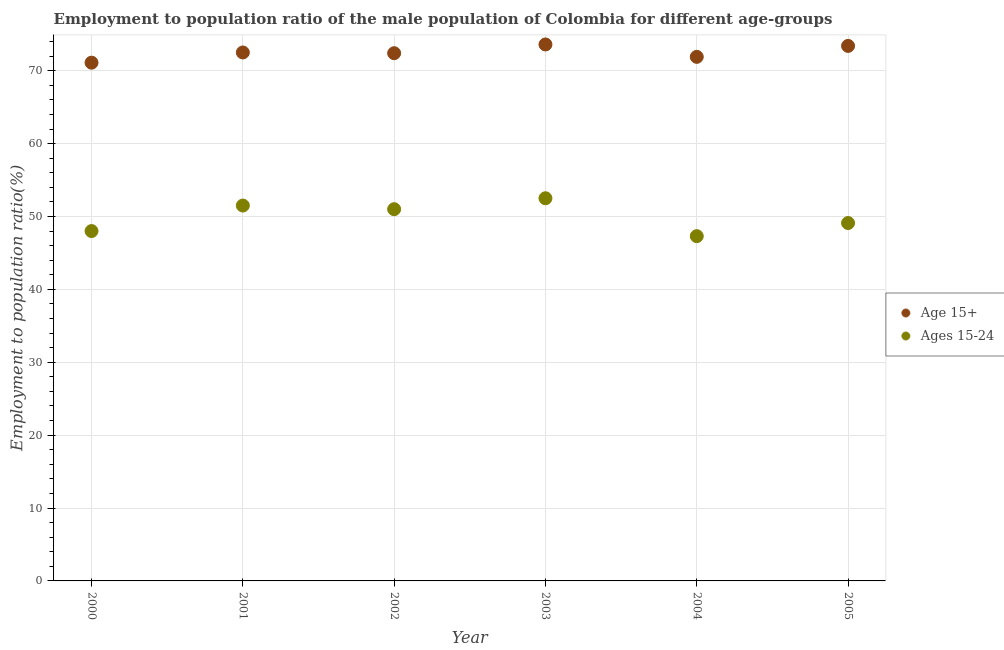How many different coloured dotlines are there?
Your answer should be compact. 2. Is the number of dotlines equal to the number of legend labels?
Ensure brevity in your answer.  Yes. What is the employment to population ratio(age 15-24) in 2001?
Offer a terse response. 51.5. Across all years, what is the maximum employment to population ratio(age 15+)?
Your response must be concise. 73.6. Across all years, what is the minimum employment to population ratio(age 15-24)?
Offer a terse response. 47.3. In which year was the employment to population ratio(age 15+) minimum?
Your answer should be compact. 2000. What is the total employment to population ratio(age 15+) in the graph?
Offer a very short reply. 434.9. What is the difference between the employment to population ratio(age 15-24) in 2002 and that in 2003?
Keep it short and to the point. -1.5. What is the difference between the employment to population ratio(age 15+) in 2003 and the employment to population ratio(age 15-24) in 2002?
Offer a very short reply. 22.6. What is the average employment to population ratio(age 15+) per year?
Offer a terse response. 72.48. In the year 2004, what is the difference between the employment to population ratio(age 15+) and employment to population ratio(age 15-24)?
Make the answer very short. 24.6. In how many years, is the employment to population ratio(age 15-24) greater than 28 %?
Your response must be concise. 6. What is the ratio of the employment to population ratio(age 15-24) in 2002 to that in 2003?
Provide a short and direct response. 0.97. Is the employment to population ratio(age 15+) in 2000 less than that in 2004?
Make the answer very short. Yes. What is the difference between the highest and the second highest employment to population ratio(age 15+)?
Provide a short and direct response. 0.2. In how many years, is the employment to population ratio(age 15-24) greater than the average employment to population ratio(age 15-24) taken over all years?
Ensure brevity in your answer.  3. Is the sum of the employment to population ratio(age 15-24) in 2000 and 2002 greater than the maximum employment to population ratio(age 15+) across all years?
Ensure brevity in your answer.  Yes. Does the employment to population ratio(age 15+) monotonically increase over the years?
Provide a short and direct response. No. Is the employment to population ratio(age 15-24) strictly greater than the employment to population ratio(age 15+) over the years?
Provide a short and direct response. No. Is the employment to population ratio(age 15-24) strictly less than the employment to population ratio(age 15+) over the years?
Your response must be concise. Yes. How many years are there in the graph?
Your answer should be compact. 6. Does the graph contain grids?
Offer a terse response. Yes. How many legend labels are there?
Offer a very short reply. 2. What is the title of the graph?
Make the answer very short. Employment to population ratio of the male population of Colombia for different age-groups. What is the label or title of the Y-axis?
Offer a very short reply. Employment to population ratio(%). What is the Employment to population ratio(%) in Age 15+ in 2000?
Ensure brevity in your answer.  71.1. What is the Employment to population ratio(%) of Age 15+ in 2001?
Ensure brevity in your answer.  72.5. What is the Employment to population ratio(%) in Ages 15-24 in 2001?
Keep it short and to the point. 51.5. What is the Employment to population ratio(%) of Age 15+ in 2002?
Ensure brevity in your answer.  72.4. What is the Employment to population ratio(%) of Age 15+ in 2003?
Give a very brief answer. 73.6. What is the Employment to population ratio(%) of Ages 15-24 in 2003?
Offer a terse response. 52.5. What is the Employment to population ratio(%) in Age 15+ in 2004?
Offer a very short reply. 71.9. What is the Employment to population ratio(%) of Ages 15-24 in 2004?
Offer a terse response. 47.3. What is the Employment to population ratio(%) in Age 15+ in 2005?
Your answer should be very brief. 73.4. What is the Employment to population ratio(%) in Ages 15-24 in 2005?
Your answer should be very brief. 49.1. Across all years, what is the maximum Employment to population ratio(%) in Age 15+?
Ensure brevity in your answer.  73.6. Across all years, what is the maximum Employment to population ratio(%) of Ages 15-24?
Your answer should be compact. 52.5. Across all years, what is the minimum Employment to population ratio(%) in Age 15+?
Your answer should be very brief. 71.1. Across all years, what is the minimum Employment to population ratio(%) of Ages 15-24?
Give a very brief answer. 47.3. What is the total Employment to population ratio(%) in Age 15+ in the graph?
Provide a succinct answer. 434.9. What is the total Employment to population ratio(%) in Ages 15-24 in the graph?
Your answer should be very brief. 299.4. What is the difference between the Employment to population ratio(%) of Ages 15-24 in 2000 and that in 2002?
Provide a short and direct response. -3. What is the difference between the Employment to population ratio(%) in Age 15+ in 2000 and that in 2004?
Keep it short and to the point. -0.8. What is the difference between the Employment to population ratio(%) of Ages 15-24 in 2000 and that in 2004?
Offer a very short reply. 0.7. What is the difference between the Employment to population ratio(%) in Ages 15-24 in 2000 and that in 2005?
Provide a succinct answer. -1.1. What is the difference between the Employment to population ratio(%) in Age 15+ in 2001 and that in 2002?
Your answer should be compact. 0.1. What is the difference between the Employment to population ratio(%) in Ages 15-24 in 2001 and that in 2002?
Give a very brief answer. 0.5. What is the difference between the Employment to population ratio(%) of Age 15+ in 2001 and that in 2003?
Offer a very short reply. -1.1. What is the difference between the Employment to population ratio(%) in Age 15+ in 2001 and that in 2005?
Provide a short and direct response. -0.9. What is the difference between the Employment to population ratio(%) in Ages 15-24 in 2002 and that in 2003?
Your answer should be very brief. -1.5. What is the difference between the Employment to population ratio(%) of Age 15+ in 2002 and that in 2004?
Your response must be concise. 0.5. What is the difference between the Employment to population ratio(%) in Age 15+ in 2003 and that in 2005?
Ensure brevity in your answer.  0.2. What is the difference between the Employment to population ratio(%) in Age 15+ in 2000 and the Employment to population ratio(%) in Ages 15-24 in 2001?
Provide a short and direct response. 19.6. What is the difference between the Employment to population ratio(%) in Age 15+ in 2000 and the Employment to population ratio(%) in Ages 15-24 in 2002?
Your response must be concise. 20.1. What is the difference between the Employment to population ratio(%) of Age 15+ in 2000 and the Employment to population ratio(%) of Ages 15-24 in 2003?
Provide a short and direct response. 18.6. What is the difference between the Employment to population ratio(%) of Age 15+ in 2000 and the Employment to population ratio(%) of Ages 15-24 in 2004?
Your answer should be compact. 23.8. What is the difference between the Employment to population ratio(%) in Age 15+ in 2000 and the Employment to population ratio(%) in Ages 15-24 in 2005?
Offer a terse response. 22. What is the difference between the Employment to population ratio(%) of Age 15+ in 2001 and the Employment to population ratio(%) of Ages 15-24 in 2002?
Make the answer very short. 21.5. What is the difference between the Employment to population ratio(%) of Age 15+ in 2001 and the Employment to population ratio(%) of Ages 15-24 in 2003?
Offer a very short reply. 20. What is the difference between the Employment to population ratio(%) in Age 15+ in 2001 and the Employment to population ratio(%) in Ages 15-24 in 2004?
Your response must be concise. 25.2. What is the difference between the Employment to population ratio(%) of Age 15+ in 2001 and the Employment to population ratio(%) of Ages 15-24 in 2005?
Your answer should be compact. 23.4. What is the difference between the Employment to population ratio(%) in Age 15+ in 2002 and the Employment to population ratio(%) in Ages 15-24 in 2003?
Offer a very short reply. 19.9. What is the difference between the Employment to population ratio(%) of Age 15+ in 2002 and the Employment to population ratio(%) of Ages 15-24 in 2004?
Keep it short and to the point. 25.1. What is the difference between the Employment to population ratio(%) in Age 15+ in 2002 and the Employment to population ratio(%) in Ages 15-24 in 2005?
Ensure brevity in your answer.  23.3. What is the difference between the Employment to population ratio(%) of Age 15+ in 2003 and the Employment to population ratio(%) of Ages 15-24 in 2004?
Ensure brevity in your answer.  26.3. What is the difference between the Employment to population ratio(%) of Age 15+ in 2003 and the Employment to population ratio(%) of Ages 15-24 in 2005?
Your answer should be very brief. 24.5. What is the difference between the Employment to population ratio(%) of Age 15+ in 2004 and the Employment to population ratio(%) of Ages 15-24 in 2005?
Ensure brevity in your answer.  22.8. What is the average Employment to population ratio(%) in Age 15+ per year?
Offer a very short reply. 72.48. What is the average Employment to population ratio(%) in Ages 15-24 per year?
Your response must be concise. 49.9. In the year 2000, what is the difference between the Employment to population ratio(%) in Age 15+ and Employment to population ratio(%) in Ages 15-24?
Give a very brief answer. 23.1. In the year 2002, what is the difference between the Employment to population ratio(%) in Age 15+ and Employment to population ratio(%) in Ages 15-24?
Your answer should be very brief. 21.4. In the year 2003, what is the difference between the Employment to population ratio(%) of Age 15+ and Employment to population ratio(%) of Ages 15-24?
Keep it short and to the point. 21.1. In the year 2004, what is the difference between the Employment to population ratio(%) of Age 15+ and Employment to population ratio(%) of Ages 15-24?
Your answer should be very brief. 24.6. In the year 2005, what is the difference between the Employment to population ratio(%) of Age 15+ and Employment to population ratio(%) of Ages 15-24?
Your answer should be very brief. 24.3. What is the ratio of the Employment to population ratio(%) in Age 15+ in 2000 to that in 2001?
Your answer should be compact. 0.98. What is the ratio of the Employment to population ratio(%) in Ages 15-24 in 2000 to that in 2001?
Give a very brief answer. 0.93. What is the ratio of the Employment to population ratio(%) in Age 15+ in 2000 to that in 2003?
Your answer should be compact. 0.97. What is the ratio of the Employment to population ratio(%) in Ages 15-24 in 2000 to that in 2003?
Offer a terse response. 0.91. What is the ratio of the Employment to population ratio(%) in Age 15+ in 2000 to that in 2004?
Make the answer very short. 0.99. What is the ratio of the Employment to population ratio(%) of Ages 15-24 in 2000 to that in 2004?
Your answer should be compact. 1.01. What is the ratio of the Employment to population ratio(%) of Age 15+ in 2000 to that in 2005?
Your response must be concise. 0.97. What is the ratio of the Employment to population ratio(%) in Ages 15-24 in 2000 to that in 2005?
Offer a very short reply. 0.98. What is the ratio of the Employment to population ratio(%) in Ages 15-24 in 2001 to that in 2002?
Provide a succinct answer. 1.01. What is the ratio of the Employment to population ratio(%) of Age 15+ in 2001 to that in 2003?
Ensure brevity in your answer.  0.99. What is the ratio of the Employment to population ratio(%) in Ages 15-24 in 2001 to that in 2003?
Your answer should be very brief. 0.98. What is the ratio of the Employment to population ratio(%) of Age 15+ in 2001 to that in 2004?
Your response must be concise. 1.01. What is the ratio of the Employment to population ratio(%) in Ages 15-24 in 2001 to that in 2004?
Offer a very short reply. 1.09. What is the ratio of the Employment to population ratio(%) of Ages 15-24 in 2001 to that in 2005?
Your response must be concise. 1.05. What is the ratio of the Employment to population ratio(%) in Age 15+ in 2002 to that in 2003?
Offer a terse response. 0.98. What is the ratio of the Employment to population ratio(%) in Ages 15-24 in 2002 to that in 2003?
Offer a very short reply. 0.97. What is the ratio of the Employment to population ratio(%) of Ages 15-24 in 2002 to that in 2004?
Offer a terse response. 1.08. What is the ratio of the Employment to population ratio(%) in Age 15+ in 2002 to that in 2005?
Provide a succinct answer. 0.99. What is the ratio of the Employment to population ratio(%) in Ages 15-24 in 2002 to that in 2005?
Your answer should be compact. 1.04. What is the ratio of the Employment to population ratio(%) of Age 15+ in 2003 to that in 2004?
Provide a short and direct response. 1.02. What is the ratio of the Employment to population ratio(%) of Ages 15-24 in 2003 to that in 2004?
Give a very brief answer. 1.11. What is the ratio of the Employment to population ratio(%) of Ages 15-24 in 2003 to that in 2005?
Your answer should be compact. 1.07. What is the ratio of the Employment to population ratio(%) of Age 15+ in 2004 to that in 2005?
Offer a very short reply. 0.98. What is the ratio of the Employment to population ratio(%) in Ages 15-24 in 2004 to that in 2005?
Make the answer very short. 0.96. What is the difference between the highest and the second highest Employment to population ratio(%) in Age 15+?
Give a very brief answer. 0.2. What is the difference between the highest and the second highest Employment to population ratio(%) in Ages 15-24?
Offer a terse response. 1. What is the difference between the highest and the lowest Employment to population ratio(%) of Ages 15-24?
Make the answer very short. 5.2. 